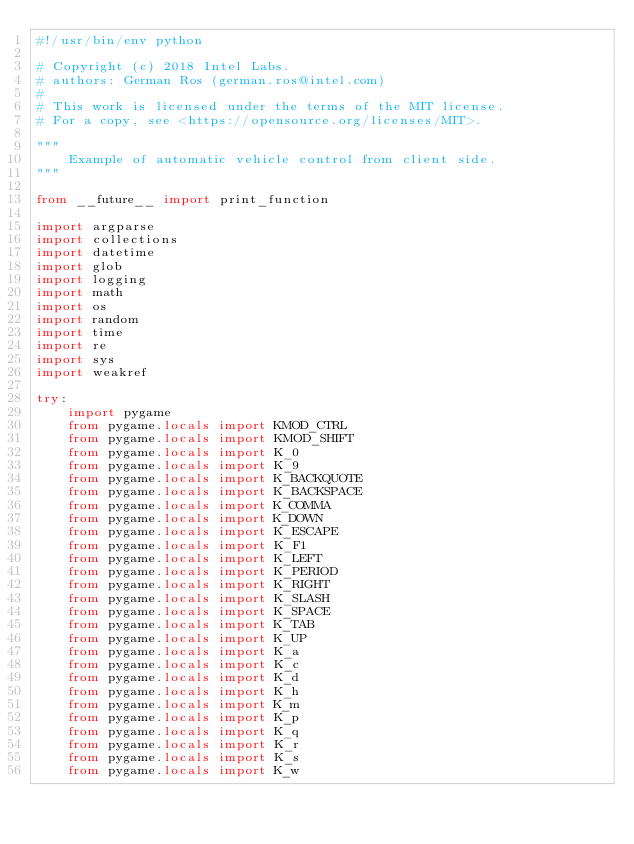<code> <loc_0><loc_0><loc_500><loc_500><_Python_>#!/usr/bin/env python

# Copyright (c) 2018 Intel Labs.
# authors: German Ros (german.ros@intel.com)
#
# This work is licensed under the terms of the MIT license.
# For a copy, see <https://opensource.org/licenses/MIT>.

"""
    Example of automatic vehicle control from client side.
"""

from __future__ import print_function

import argparse
import collections
import datetime
import glob
import logging
import math
import os
import random
import time
import re
import sys
import weakref

try:
    import pygame
    from pygame.locals import KMOD_CTRL
    from pygame.locals import KMOD_SHIFT
    from pygame.locals import K_0
    from pygame.locals import K_9
    from pygame.locals import K_BACKQUOTE
    from pygame.locals import K_BACKSPACE
    from pygame.locals import K_COMMA
    from pygame.locals import K_DOWN
    from pygame.locals import K_ESCAPE
    from pygame.locals import K_F1
    from pygame.locals import K_LEFT
    from pygame.locals import K_PERIOD
    from pygame.locals import K_RIGHT
    from pygame.locals import K_SLASH
    from pygame.locals import K_SPACE
    from pygame.locals import K_TAB
    from pygame.locals import K_UP
    from pygame.locals import K_a
    from pygame.locals import K_c
    from pygame.locals import K_d
    from pygame.locals import K_h
    from pygame.locals import K_m
    from pygame.locals import K_p
    from pygame.locals import K_q
    from pygame.locals import K_r
    from pygame.locals import K_s
    from pygame.locals import K_w</code> 